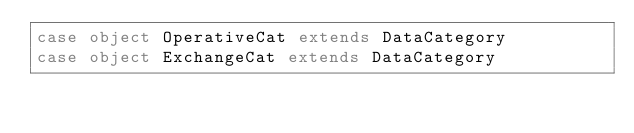Convert code to text. <code><loc_0><loc_0><loc_500><loc_500><_Scala_>case object OperativeCat extends DataCategory
case object ExchangeCat extends DataCategory</code> 